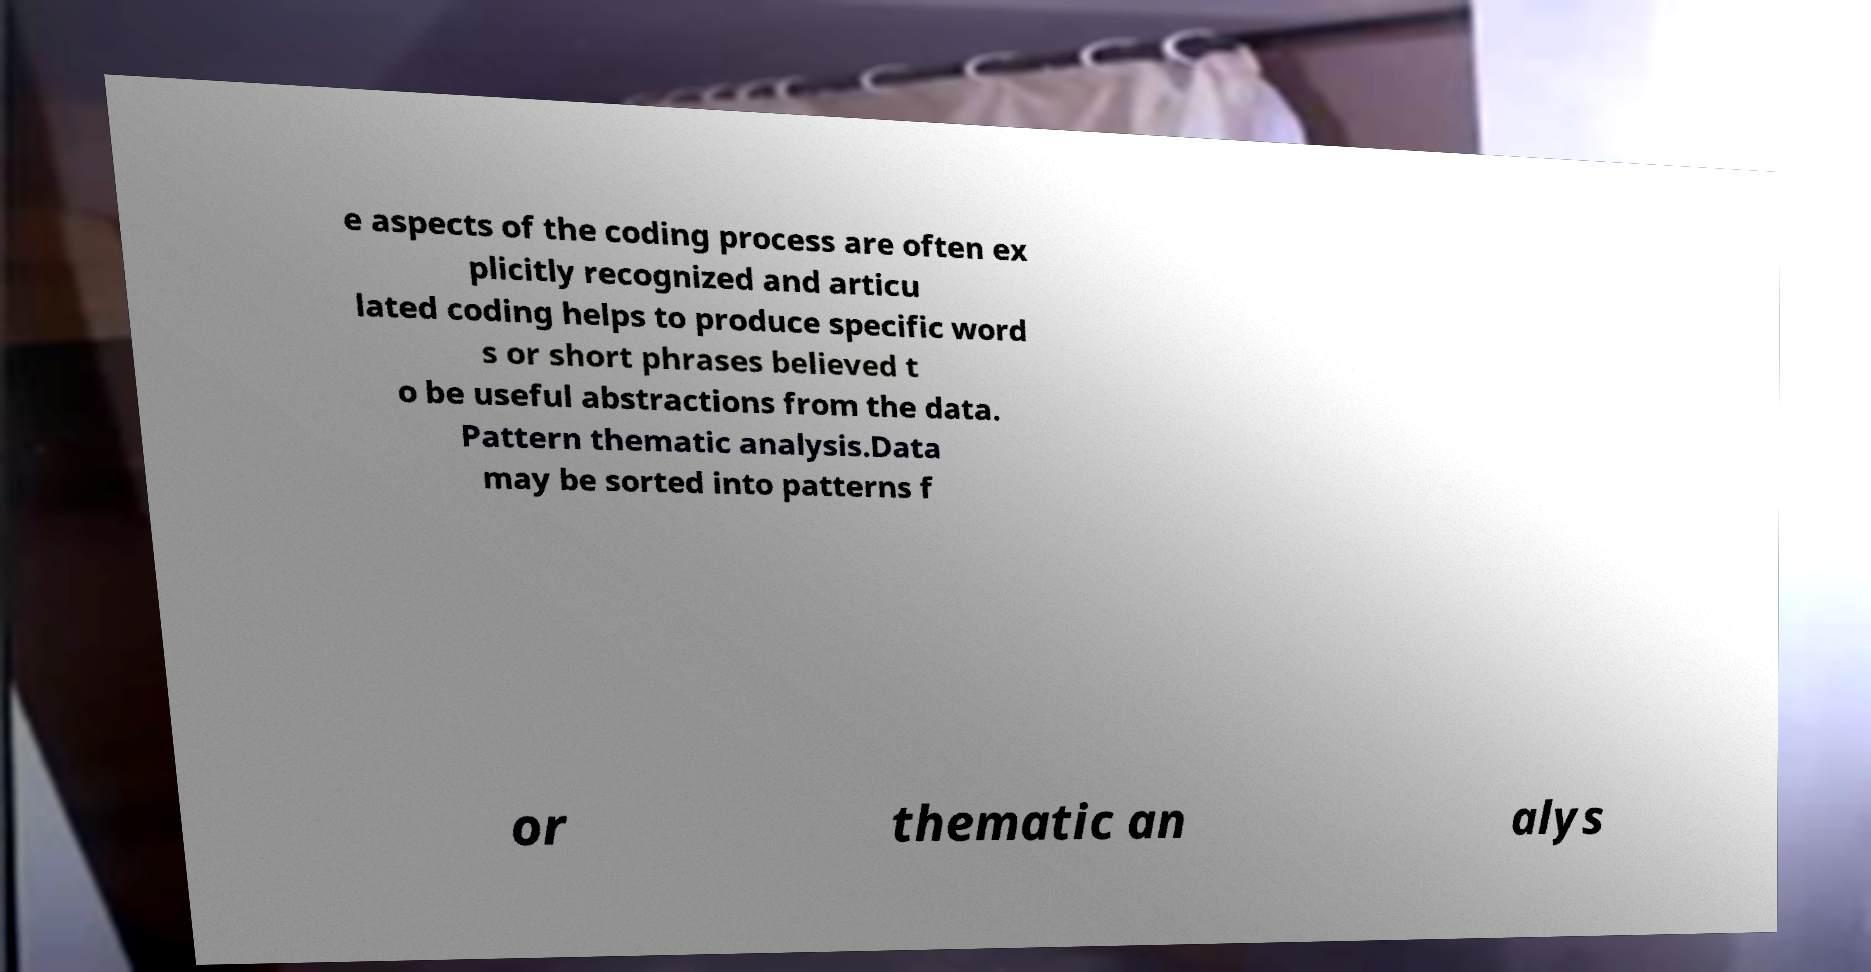There's text embedded in this image that I need extracted. Can you transcribe it verbatim? e aspects of the coding process are often ex plicitly recognized and articu lated coding helps to produce specific word s or short phrases believed t o be useful abstractions from the data. Pattern thematic analysis.Data may be sorted into patterns f or thematic an alys 